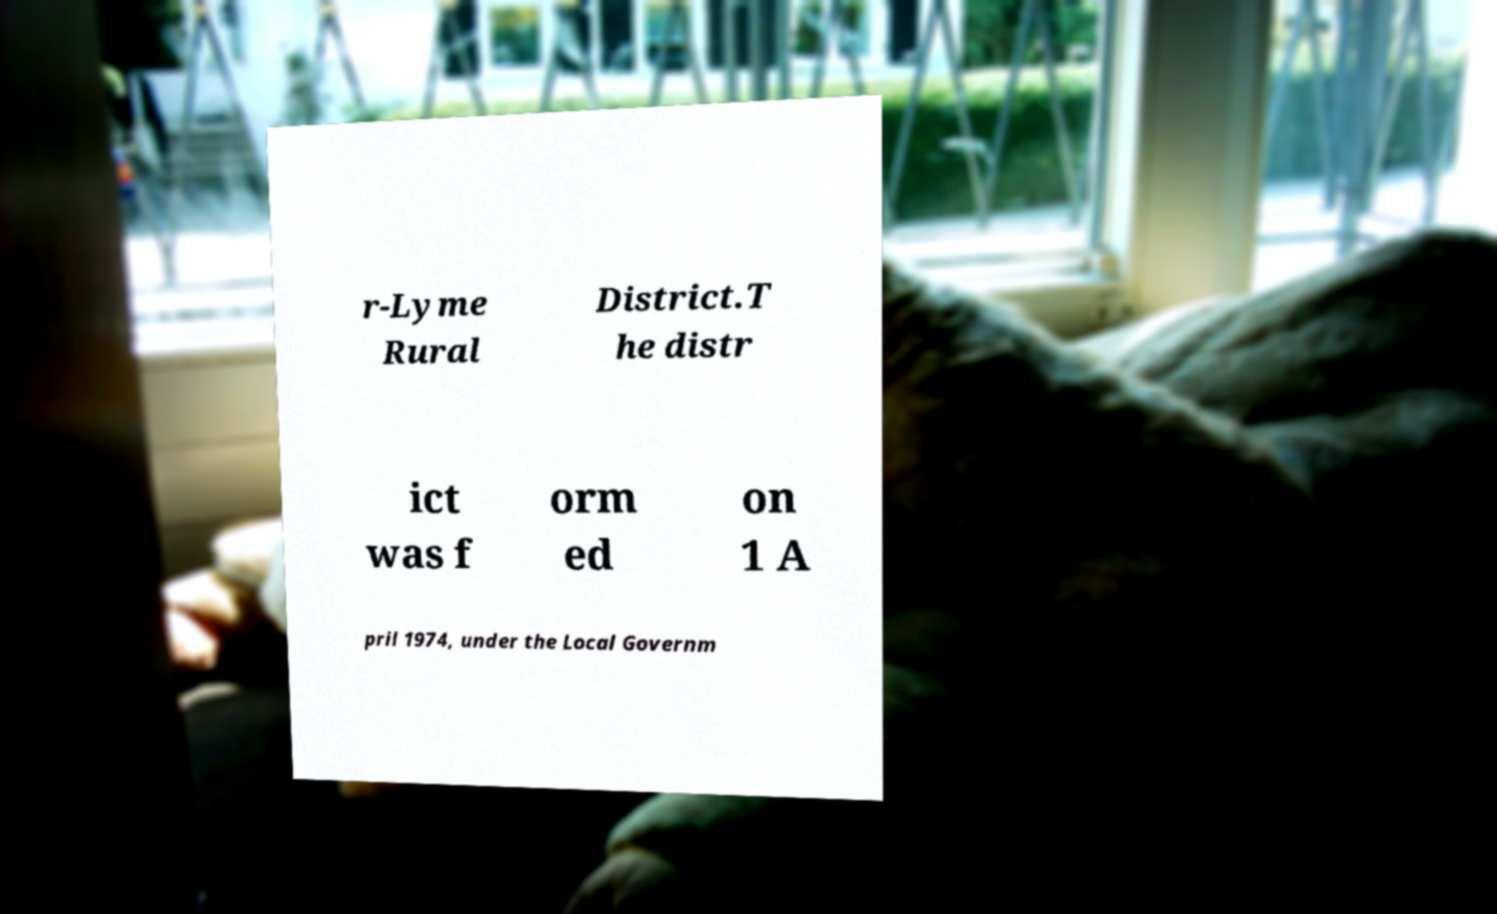Can you accurately transcribe the text from the provided image for me? r-Lyme Rural District.T he distr ict was f orm ed on 1 A pril 1974, under the Local Governm 